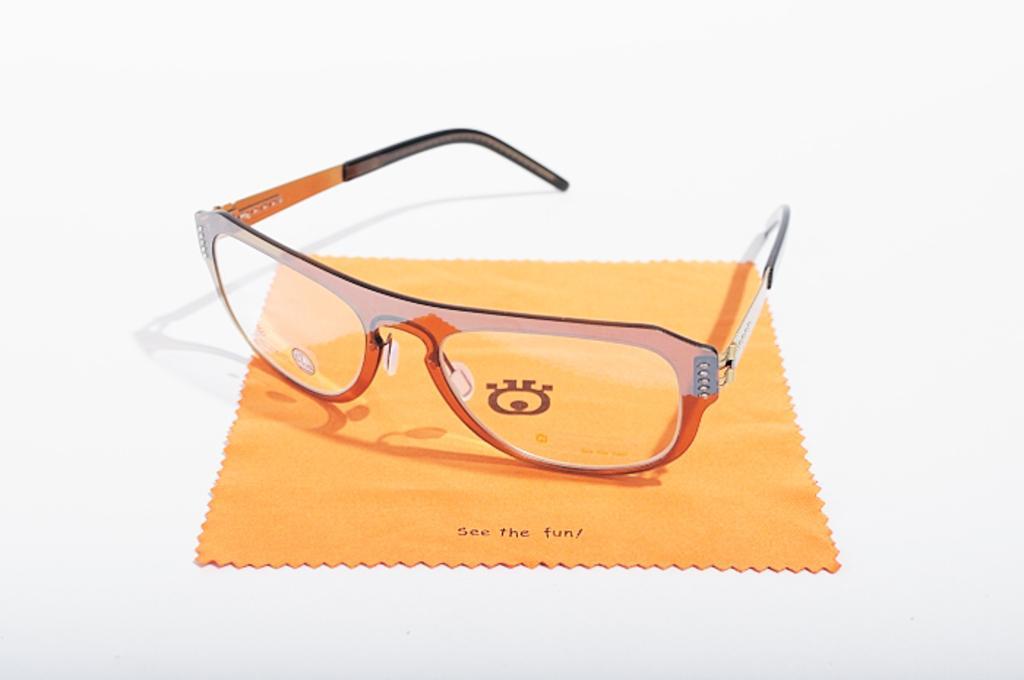Please provide a concise description of this image. The picture consists of spectacles and a cloth on a white surface. 